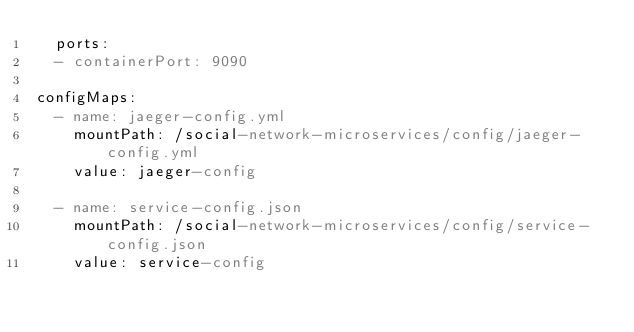<code> <loc_0><loc_0><loc_500><loc_500><_YAML_>  ports: 
  - containerPort: 9090

configMaps:
  - name: jaeger-config.yml
    mountPath: /social-network-microservices/config/jaeger-config.yml
    value: jaeger-config

  - name: service-config.json
    mountPath: /social-network-microservices/config/service-config.json
    value: service-config
</code> 